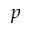<formula> <loc_0><loc_0><loc_500><loc_500>p</formula> 